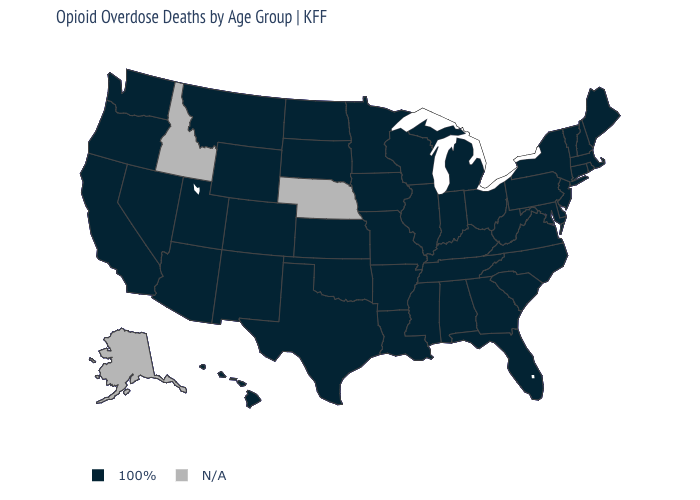Name the states that have a value in the range N/A?
Concise answer only. Alaska, Idaho, Nebraska. What is the value of Arizona?
Write a very short answer. 100%. Is the legend a continuous bar?
Write a very short answer. No. What is the value of Rhode Island?
Concise answer only. 100%. Name the states that have a value in the range N/A?
Concise answer only. Alaska, Idaho, Nebraska. What is the lowest value in the MidWest?
Answer briefly. 100%. Among the states that border Connecticut , which have the lowest value?
Quick response, please. Massachusetts, New York, Rhode Island. What is the value of Massachusetts?
Keep it brief. 100%. Name the states that have a value in the range N/A?
Keep it brief. Alaska, Idaho, Nebraska. How many symbols are there in the legend?
Write a very short answer. 2. Which states have the highest value in the USA?
Quick response, please. Alabama, Arizona, Arkansas, California, Colorado, Connecticut, Delaware, Florida, Georgia, Hawaii, Illinois, Indiana, Iowa, Kansas, Kentucky, Louisiana, Maine, Maryland, Massachusetts, Michigan, Minnesota, Mississippi, Missouri, Montana, Nevada, New Hampshire, New Jersey, New Mexico, New York, North Carolina, North Dakota, Ohio, Oklahoma, Oregon, Pennsylvania, Rhode Island, South Carolina, South Dakota, Tennessee, Texas, Utah, Vermont, Virginia, Washington, West Virginia, Wisconsin, Wyoming. What is the lowest value in states that border Nebraska?
Be succinct. 100%. How many symbols are there in the legend?
Answer briefly. 2. Does the first symbol in the legend represent the smallest category?
Write a very short answer. Yes. 